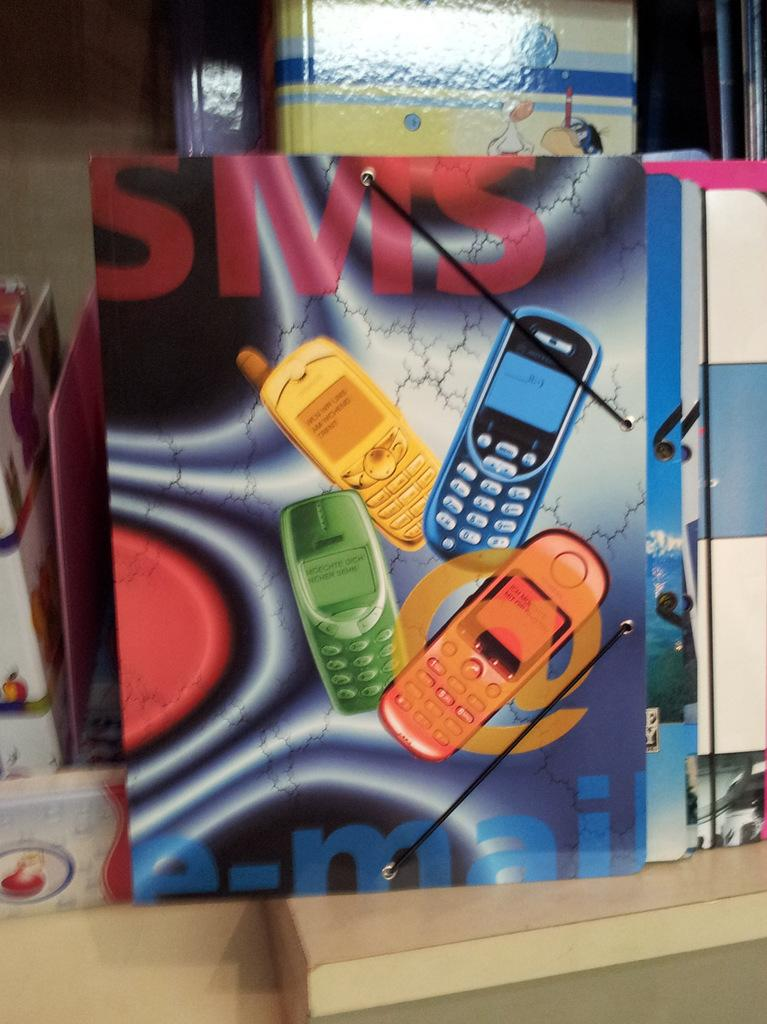Provide a one-sentence caption for the provided image. colorful cell phones with the words SMS and e-mail by the side. 